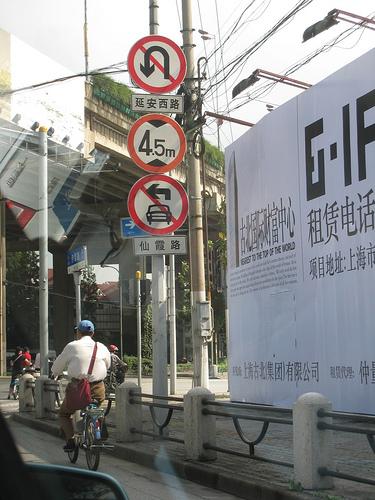What colors are the three signs?
Answer briefly. White. What is the man behind the table waiting for?
Answer briefly. Nothing. How many "do not U turn" signs are there in this picture?
Be succinct. 1. What the top sign say you can't do?
Be succinct. U-turn. 